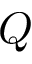<formula> <loc_0><loc_0><loc_500><loc_500>Q</formula> 